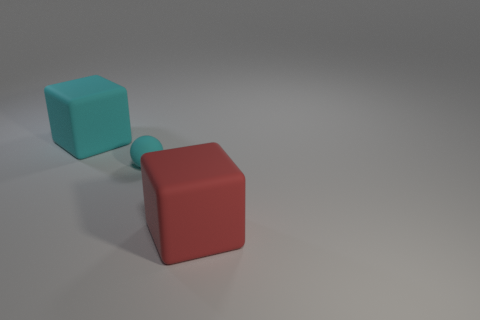Could you describe the lighting and shadows present in the scene? The scene is lit from above and to the right, producing soft shadows that extend to the lower left of the objects. This lighting suggests a single, diffused light source, which creates a calm and simple mood. How does the shadowing affect our perception of the cube's size? The shadowing enhances the three-dimensional effect and gives a sense of depth, which helps our perception in estimating the cubes' size more accurately, confirming that they are indeed similar in size. 